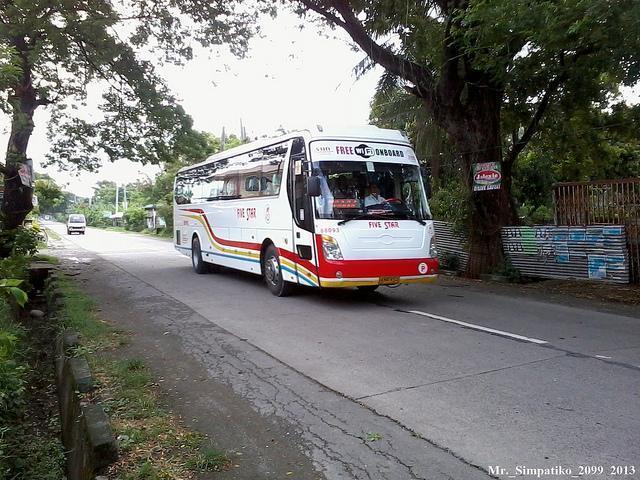What complimentary service does the bus offer on board?
Select the accurate answer and provide explanation: 'Answer: answer
Rationale: rationale.'
Options: Air-conditioner, restrooms, wi-fi, movies. Answer: wi-fi.
Rationale: More of a recent amenity with buses, wifi is accessible. 